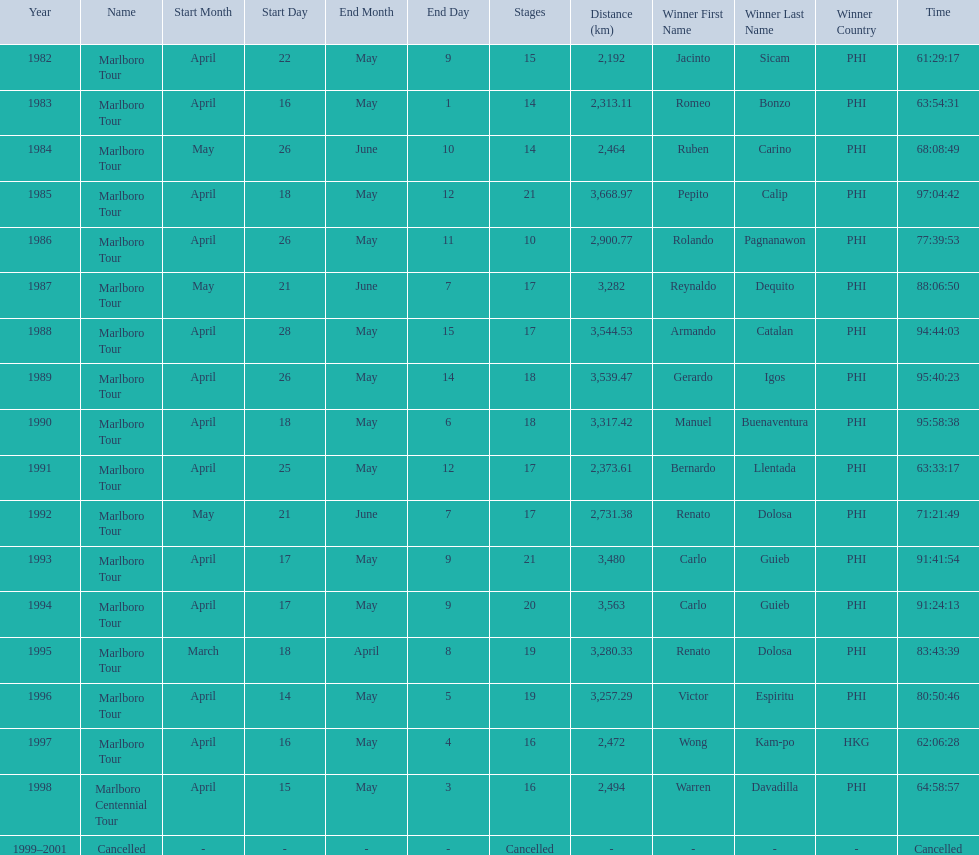Who was the only winner to have their time below 61:45:00? Jacinto Sicam. 